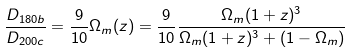<formula> <loc_0><loc_0><loc_500><loc_500>\frac { D _ { 1 8 0 b } } { D _ { 2 0 0 c } } = \frac { 9 } { 1 0 } \Omega _ { m } ( z ) = \frac { 9 } { 1 0 } \frac { \Omega _ { m } ( 1 + z ) ^ { 3 } } { \Omega _ { m } ( 1 + z ) ^ { 3 } + ( 1 - \Omega _ { m } ) }</formula> 